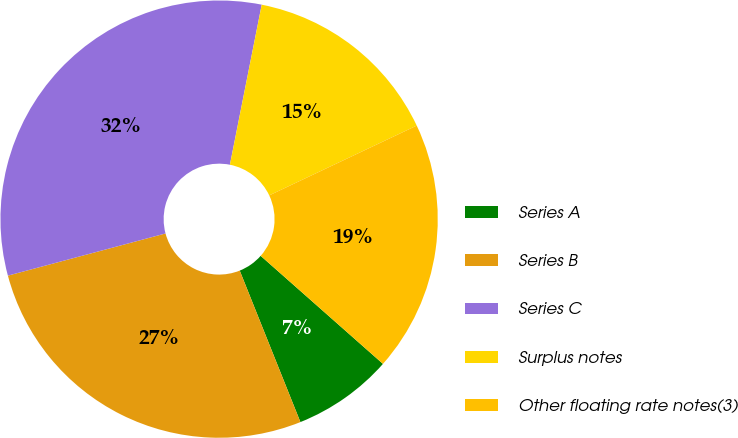Convert chart. <chart><loc_0><loc_0><loc_500><loc_500><pie_chart><fcel>Series A<fcel>Series B<fcel>Series C<fcel>Surplus notes<fcel>Other floating rate notes(3)<nl><fcel>7.42%<fcel>26.9%<fcel>32.28%<fcel>14.84%<fcel>18.55%<nl></chart> 